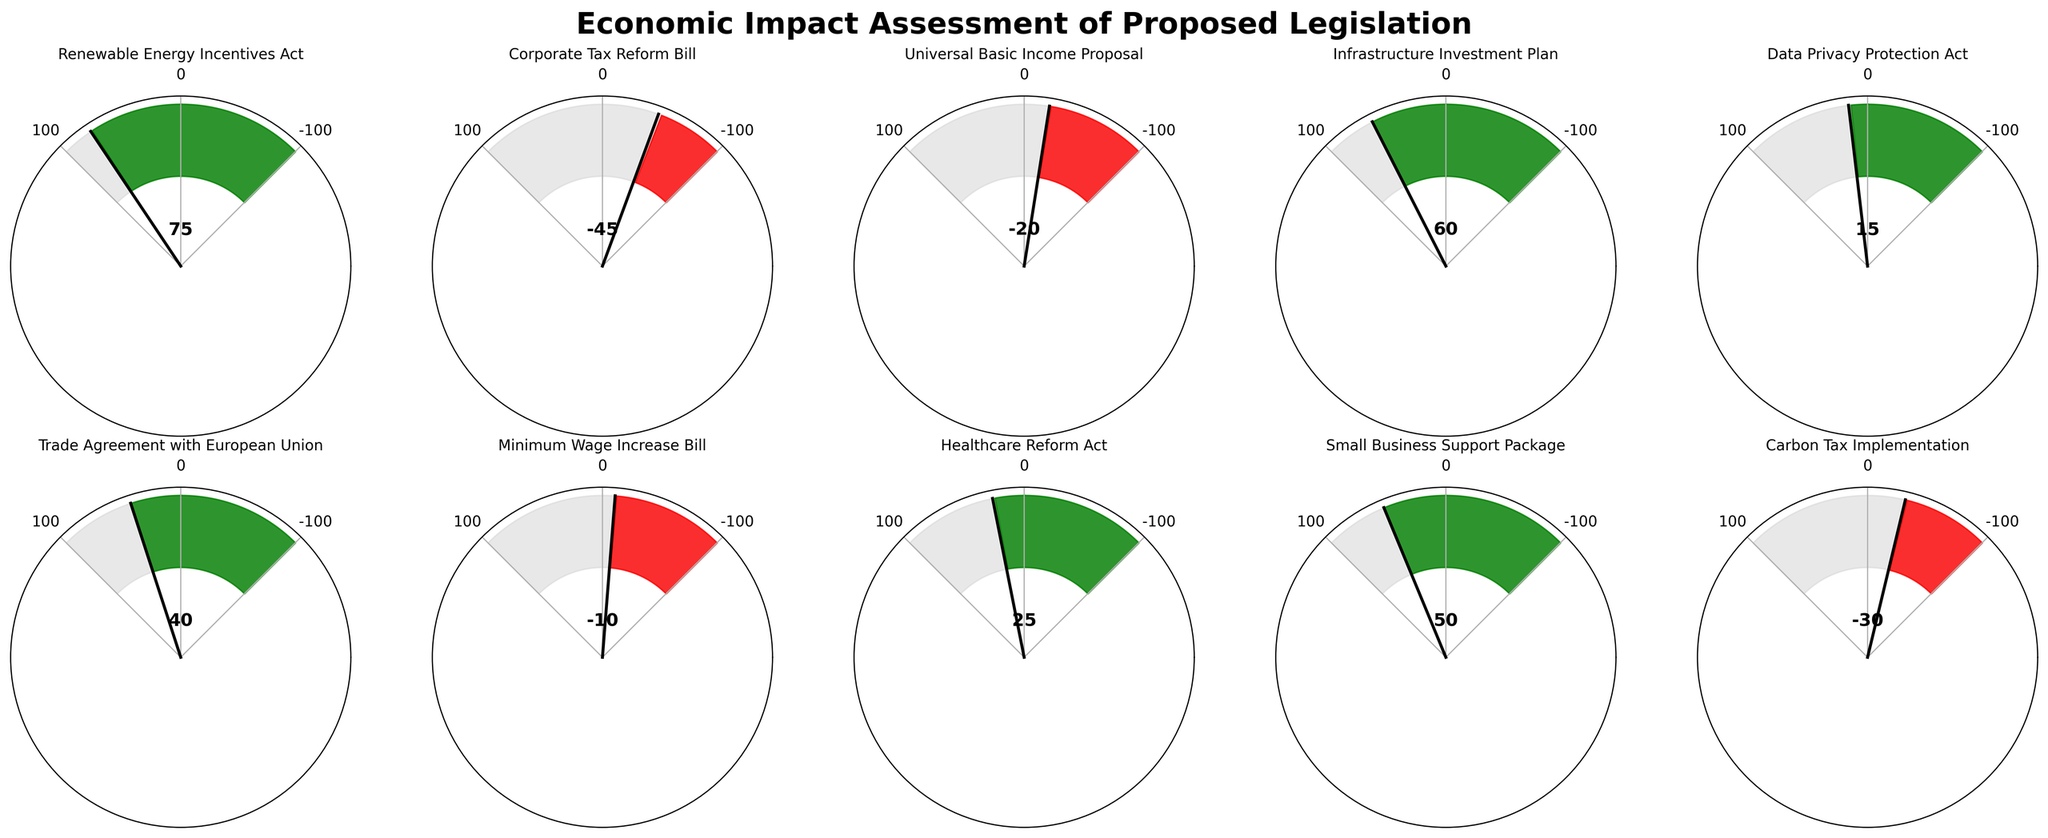What is the title of the plot? The title is located at the top of the plot and is written in a larger and bold font. It reads "Economic Impact Assessment of Proposed Legislation".
Answer: Economic Impact Assessment of Proposed Legislation How many pieces of legislation are assessed in the figure? By counting each subplot, we can see there are 10 separate gauge charts representing different pieces of legislation.
Answer: 10 Which piece of legislation has the highest positive economic impact? By comparing the impact values displayed on each gauge, we see that the "Renewable Energy Incentives Act" has the highest positive economic impact with a value of 75.
Answer: Renewable Energy Incentives Act What color represents a negative economic impact? Examining the colored gauges, it is apparent that red denotes a negative economic impact.
Answer: Red What is the combined economic impact of both the "Infrastructure Investment Plan" and the "Trade Agreement with European Union"? Adding the values for these two legislations, we find 60 (Infrastructure Investment Plan) + 40 (Trade Agreement with European Union) = 100.
Answer: 100 Which legislation has a stronger negative impact: "Corporate Tax Reform Bill" or "Minimum Wage Increase Bill"? Comparing the negative values, the "Corporate Tax Reform Bill" has a stronger negative impact of -45 compared to the "Minimum Wage Increase Bill" which has an impact of -10.
Answer: Corporate Tax Reform Bill What is the average economic impact of all assessed legislation? To calculate the average: (75 - 45 - 20 + 60 + 15 + 40 - 10 + 25 + 50 - 30) / 10 = 160 / 10 = 16.
Answer: 16 Which piece of legislation closest to a neutral economic impact? The chart for the "Data Privacy Protection Act" shows an impact of 15, which is the closest to 0 among all the legislations.
Answer: Data Privacy Protection Act 